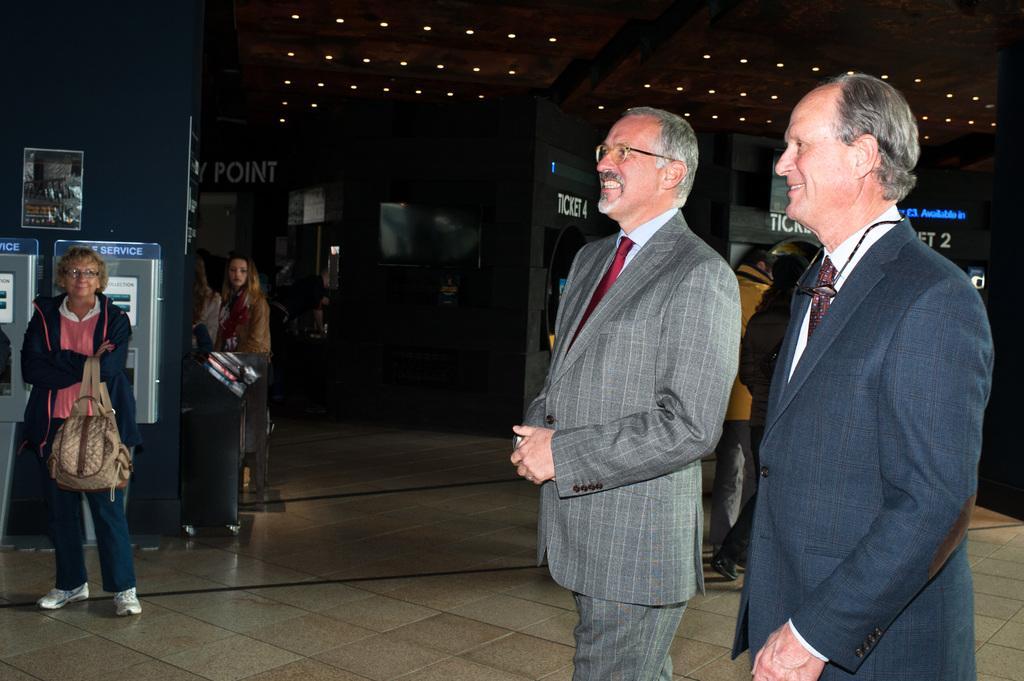Can you describe this image briefly? This is the inside picture of a building and there are people standing on the floor. There are ticket counters. On top of the image there are ceiling lights. 